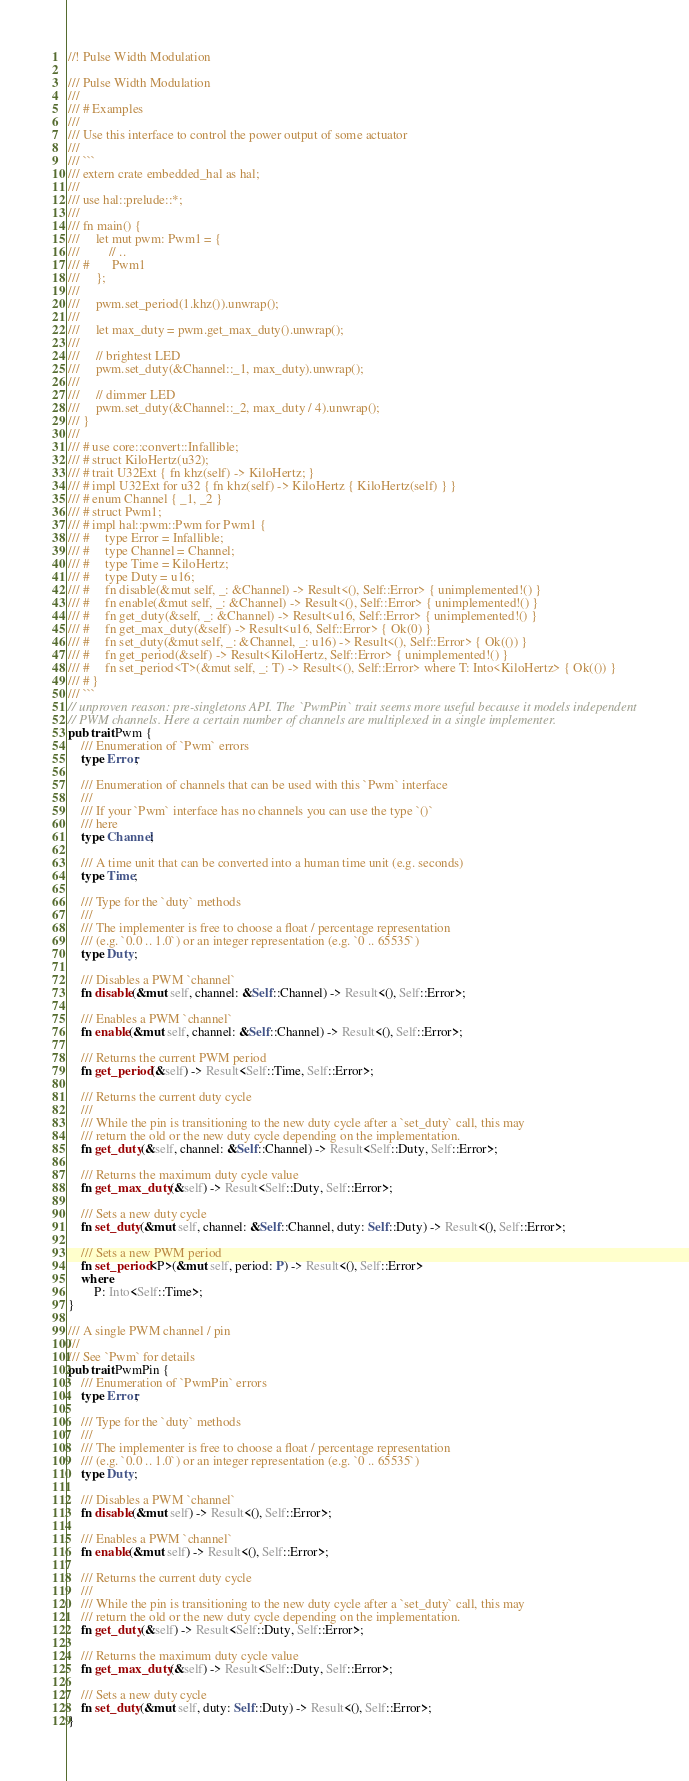Convert code to text. <code><loc_0><loc_0><loc_500><loc_500><_Rust_>//! Pulse Width Modulation

/// Pulse Width Modulation
///
/// # Examples
///
/// Use this interface to control the power output of some actuator
///
/// ```
/// extern crate embedded_hal as hal;
///
/// use hal::prelude::*;
///
/// fn main() {
///     let mut pwm: Pwm1 = {
///         // ..
/// #       Pwm1
///     };
///
///     pwm.set_period(1.khz()).unwrap();
///
///     let max_duty = pwm.get_max_duty().unwrap();
///
///     // brightest LED
///     pwm.set_duty(&Channel::_1, max_duty).unwrap();
///
///     // dimmer LED
///     pwm.set_duty(&Channel::_2, max_duty / 4).unwrap();
/// }
///
/// # use core::convert::Infallible;
/// # struct KiloHertz(u32);
/// # trait U32Ext { fn khz(self) -> KiloHertz; }
/// # impl U32Ext for u32 { fn khz(self) -> KiloHertz { KiloHertz(self) } }
/// # enum Channel { _1, _2 }
/// # struct Pwm1;
/// # impl hal::pwm::Pwm for Pwm1 {
/// #     type Error = Infallible;
/// #     type Channel = Channel;
/// #     type Time = KiloHertz;
/// #     type Duty = u16;
/// #     fn disable(&mut self, _: &Channel) -> Result<(), Self::Error> { unimplemented!() }
/// #     fn enable(&mut self, _: &Channel) -> Result<(), Self::Error> { unimplemented!() }
/// #     fn get_duty(&self, _: &Channel) -> Result<u16, Self::Error> { unimplemented!() }
/// #     fn get_max_duty(&self) -> Result<u16, Self::Error> { Ok(0) }
/// #     fn set_duty(&mut self, _: &Channel, _: u16) -> Result<(), Self::Error> { Ok(()) }
/// #     fn get_period(&self) -> Result<KiloHertz, Self::Error> { unimplemented!() }
/// #     fn set_period<T>(&mut self, _: T) -> Result<(), Self::Error> where T: Into<KiloHertz> { Ok(()) }
/// # }
/// ```
// unproven reason: pre-singletons API. The `PwmPin` trait seems more useful because it models independent
// PWM channels. Here a certain number of channels are multiplexed in a single implementer.
pub trait Pwm {
    /// Enumeration of `Pwm` errors
    type Error;

    /// Enumeration of channels that can be used with this `Pwm` interface
    ///
    /// If your `Pwm` interface has no channels you can use the type `()`
    /// here
    type Channel;

    /// A time unit that can be converted into a human time unit (e.g. seconds)
    type Time;

    /// Type for the `duty` methods
    ///
    /// The implementer is free to choose a float / percentage representation
    /// (e.g. `0.0 .. 1.0`) or an integer representation (e.g. `0 .. 65535`)
    type Duty;

    /// Disables a PWM `channel`
    fn disable(&mut self, channel: &Self::Channel) -> Result<(), Self::Error>;

    /// Enables a PWM `channel`
    fn enable(&mut self, channel: &Self::Channel) -> Result<(), Self::Error>;

    /// Returns the current PWM period
    fn get_period(&self) -> Result<Self::Time, Self::Error>;

    /// Returns the current duty cycle
    ///
    /// While the pin is transitioning to the new duty cycle after a `set_duty` call, this may
    /// return the old or the new duty cycle depending on the implementation.
    fn get_duty(&self, channel: &Self::Channel) -> Result<Self::Duty, Self::Error>;

    /// Returns the maximum duty cycle value
    fn get_max_duty(&self) -> Result<Self::Duty, Self::Error>;

    /// Sets a new duty cycle
    fn set_duty(&mut self, channel: &Self::Channel, duty: Self::Duty) -> Result<(), Self::Error>;

    /// Sets a new PWM period
    fn set_period<P>(&mut self, period: P) -> Result<(), Self::Error>
    where
        P: Into<Self::Time>;
}

/// A single PWM channel / pin
///
/// See `Pwm` for details
pub trait PwmPin {
    /// Enumeration of `PwmPin` errors
    type Error;

    /// Type for the `duty` methods
    ///
    /// The implementer is free to choose a float / percentage representation
    /// (e.g. `0.0 .. 1.0`) or an integer representation (e.g. `0 .. 65535`)
    type Duty;

    /// Disables a PWM `channel`
    fn disable(&mut self) -> Result<(), Self::Error>;

    /// Enables a PWM `channel`
    fn enable(&mut self) -> Result<(), Self::Error>;

    /// Returns the current duty cycle
    ///
    /// While the pin is transitioning to the new duty cycle after a `set_duty` call, this may
    /// return the old or the new duty cycle depending on the implementation.
    fn get_duty(&self) -> Result<Self::Duty, Self::Error>;

    /// Returns the maximum duty cycle value
    fn get_max_duty(&self) -> Result<Self::Duty, Self::Error>;

    /// Sets a new duty cycle
    fn set_duty(&mut self, duty: Self::Duty) -> Result<(), Self::Error>;
}
</code> 